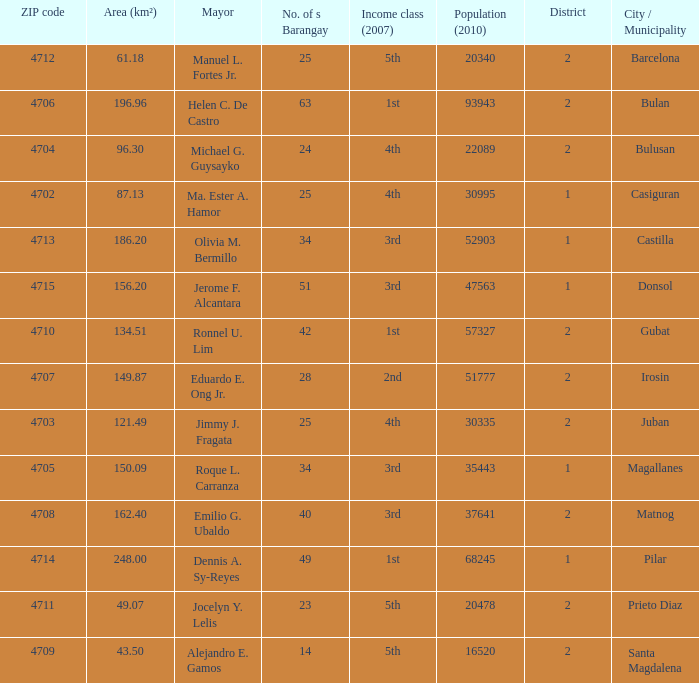What are all the vicinity (km²) where profits magnificence (2007) is 2nd 149.87. 